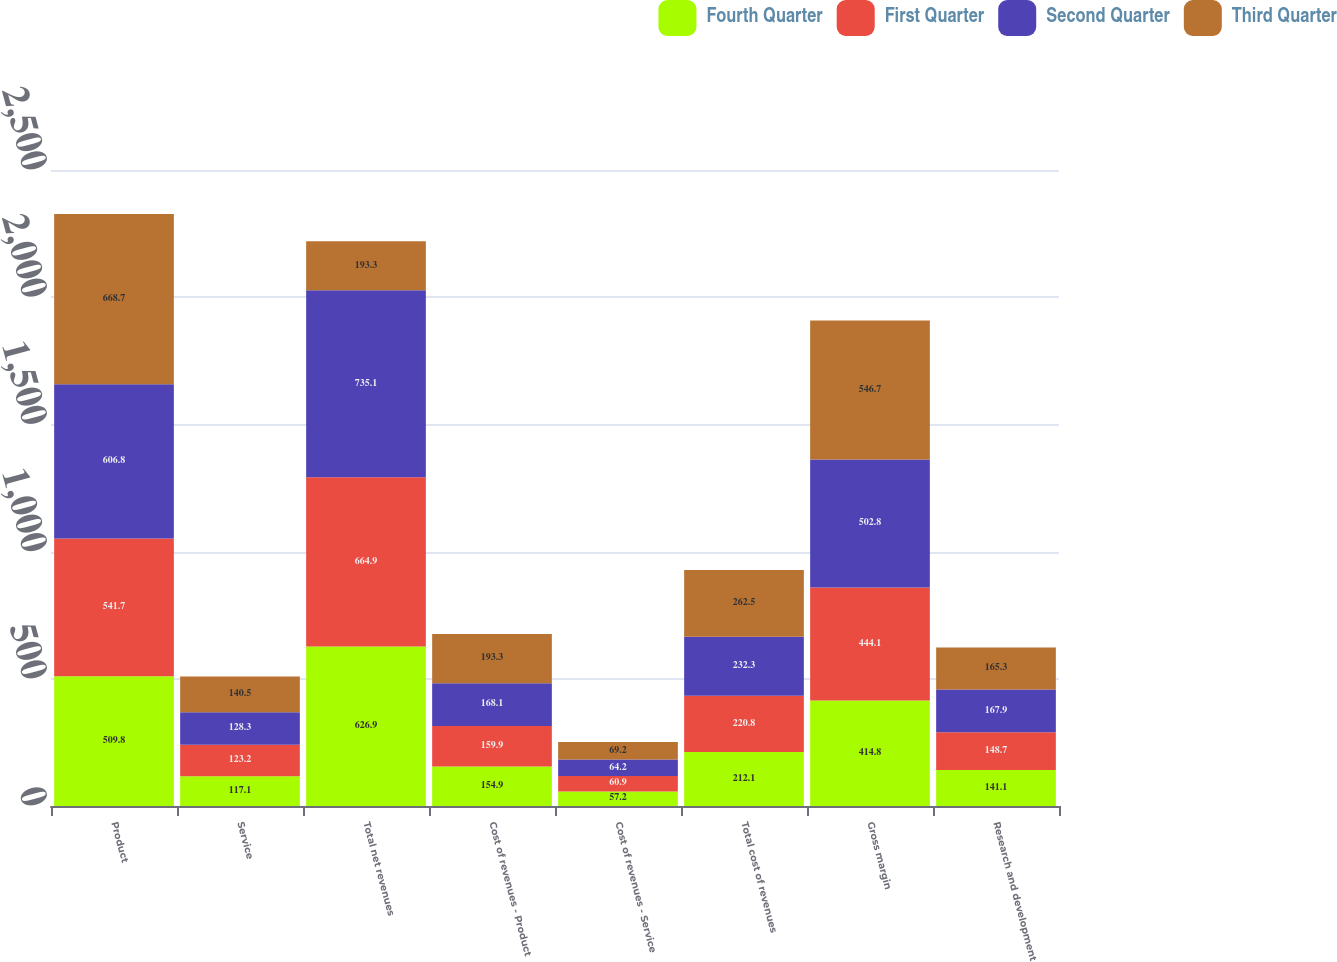<chart> <loc_0><loc_0><loc_500><loc_500><stacked_bar_chart><ecel><fcel>Product<fcel>Service<fcel>Total net revenues<fcel>Cost of revenues - Product<fcel>Cost of revenues - Service<fcel>Total cost of revenues<fcel>Gross margin<fcel>Research and development<nl><fcel>Fourth Quarter<fcel>509.8<fcel>117.1<fcel>626.9<fcel>154.9<fcel>57.2<fcel>212.1<fcel>414.8<fcel>141.1<nl><fcel>First Quarter<fcel>541.7<fcel>123.2<fcel>664.9<fcel>159.9<fcel>60.9<fcel>220.8<fcel>444.1<fcel>148.7<nl><fcel>Second Quarter<fcel>606.8<fcel>128.3<fcel>735.1<fcel>168.1<fcel>64.2<fcel>232.3<fcel>502.8<fcel>167.9<nl><fcel>Third Quarter<fcel>668.7<fcel>140.5<fcel>193.3<fcel>193.3<fcel>69.2<fcel>262.5<fcel>546.7<fcel>165.3<nl></chart> 